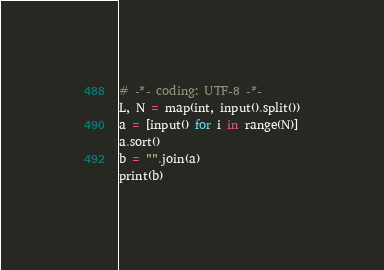<code> <loc_0><loc_0><loc_500><loc_500><_Python_># -*- coding: UTF-8 -*-
L, N = map(int, input().split())
a = [input() for i in range(N)]
a.sort()
b = "".join(a)
print(b)</code> 